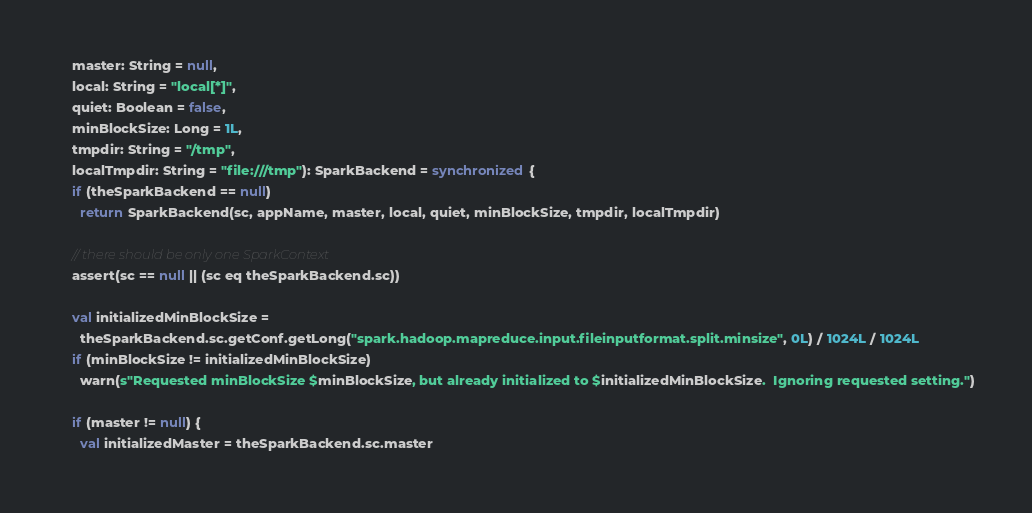Convert code to text. <code><loc_0><loc_0><loc_500><loc_500><_Scala_>    master: String = null,
    local: String = "local[*]",
    quiet: Boolean = false,
    minBlockSize: Long = 1L,
    tmpdir: String = "/tmp",
    localTmpdir: String = "file:///tmp"): SparkBackend = synchronized {
    if (theSparkBackend == null)
      return SparkBackend(sc, appName, master, local, quiet, minBlockSize, tmpdir, localTmpdir)

    // there should be only one SparkContext
    assert(sc == null || (sc eq theSparkBackend.sc))

    val initializedMinBlockSize =
      theSparkBackend.sc.getConf.getLong("spark.hadoop.mapreduce.input.fileinputformat.split.minsize", 0L) / 1024L / 1024L
    if (minBlockSize != initializedMinBlockSize)
      warn(s"Requested minBlockSize $minBlockSize, but already initialized to $initializedMinBlockSize.  Ignoring requested setting.")

    if (master != null) {
      val initializedMaster = theSparkBackend.sc.master</code> 